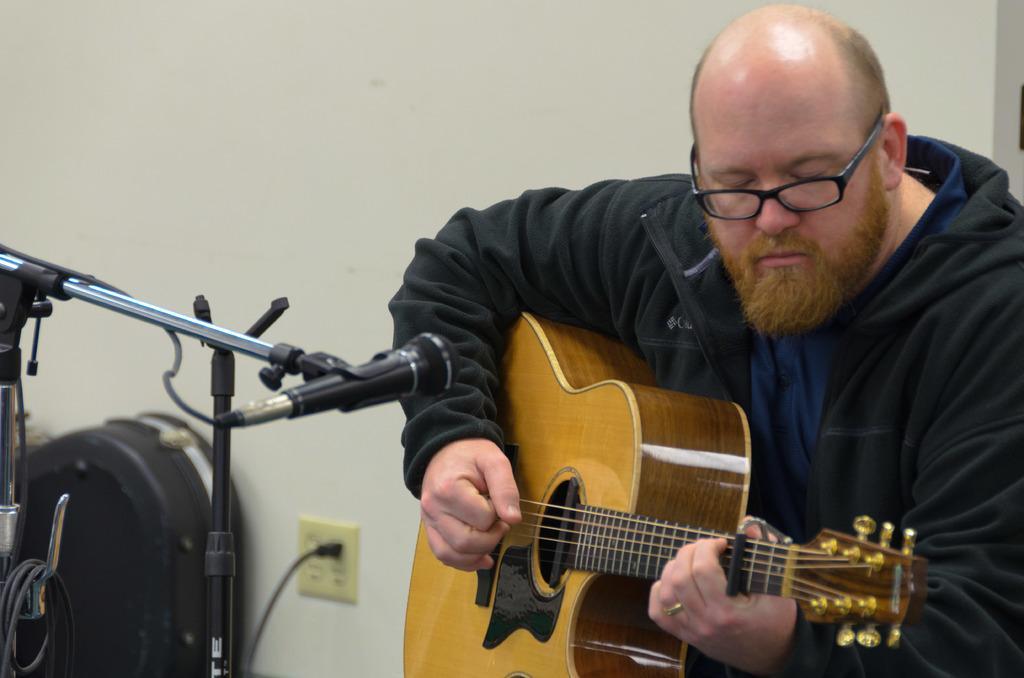Describe this image in one or two sentences. In the image in the center we can see one person playing guitar. In front of him,we can see one microphone and stand. In the background we can see wall,wire,switch board and backpack. 